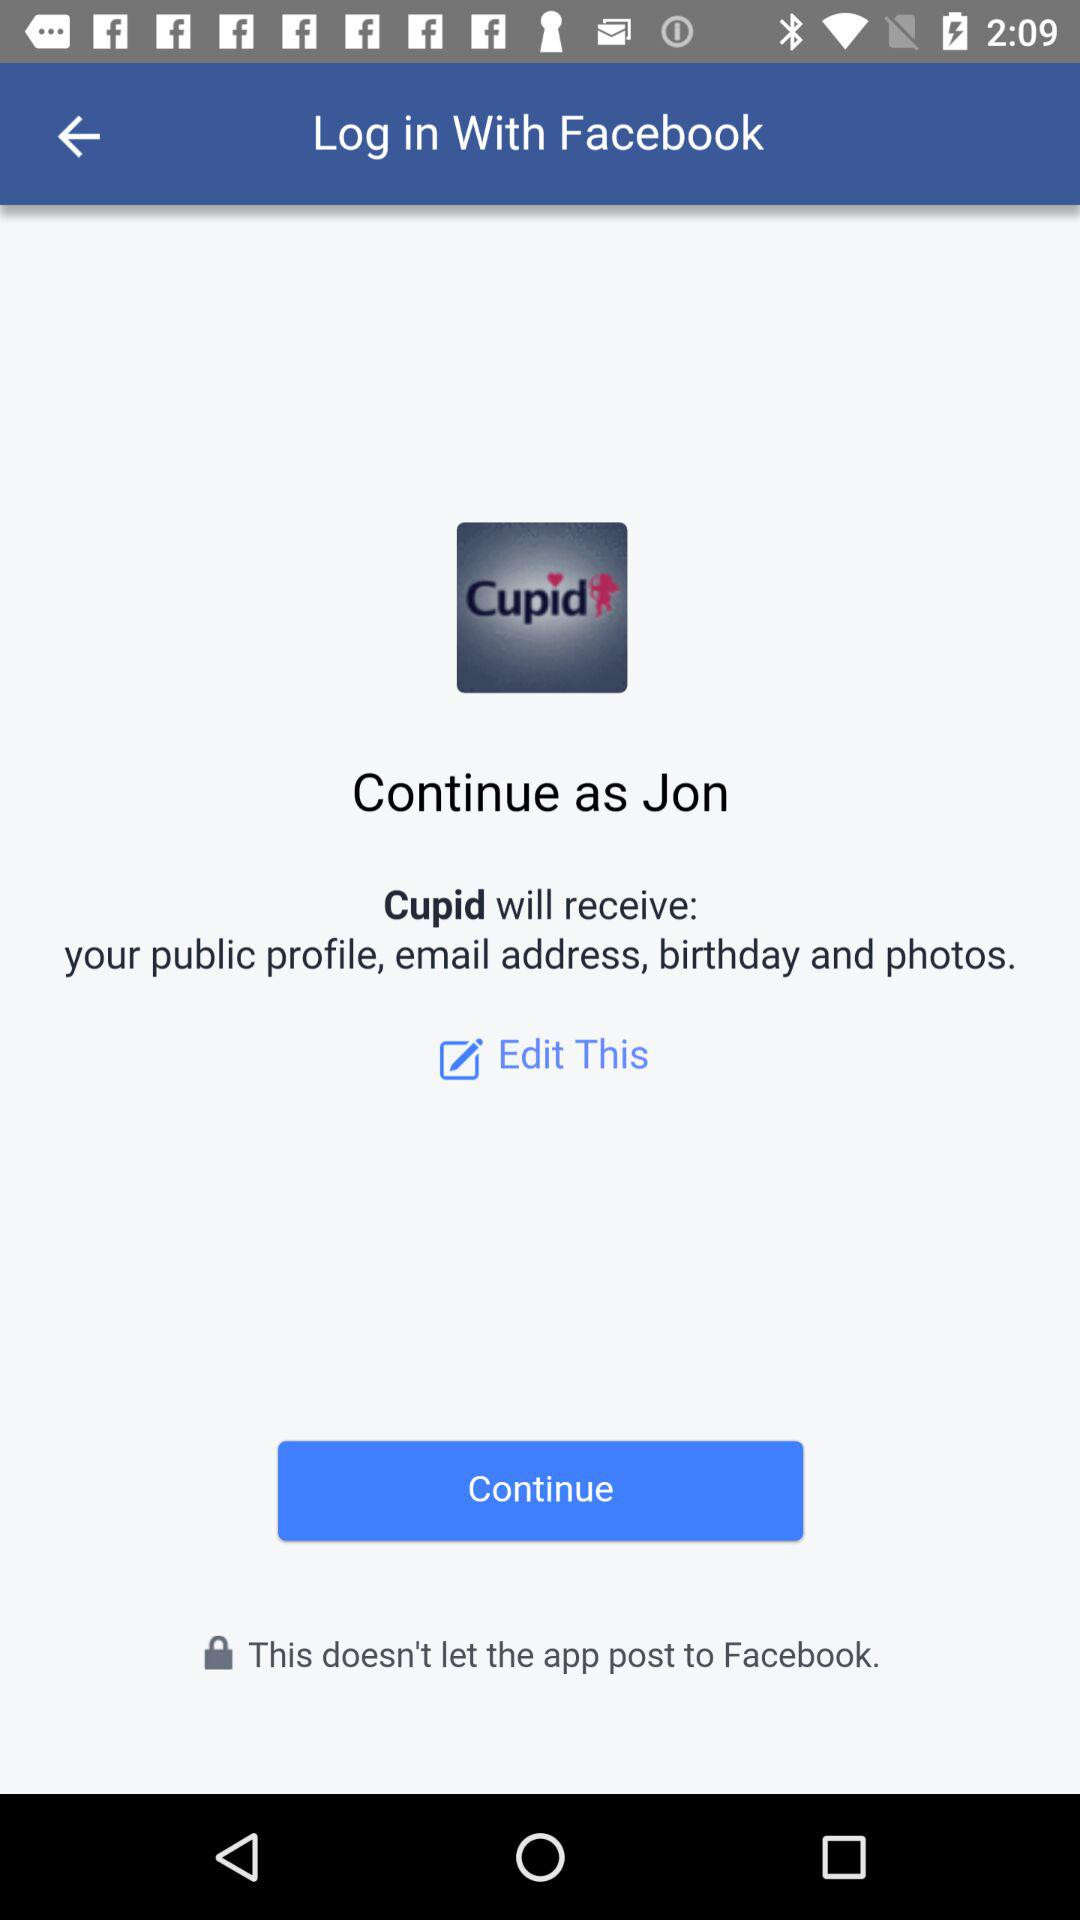What application is asking for permission? The application asking for permission is "Cupid". 